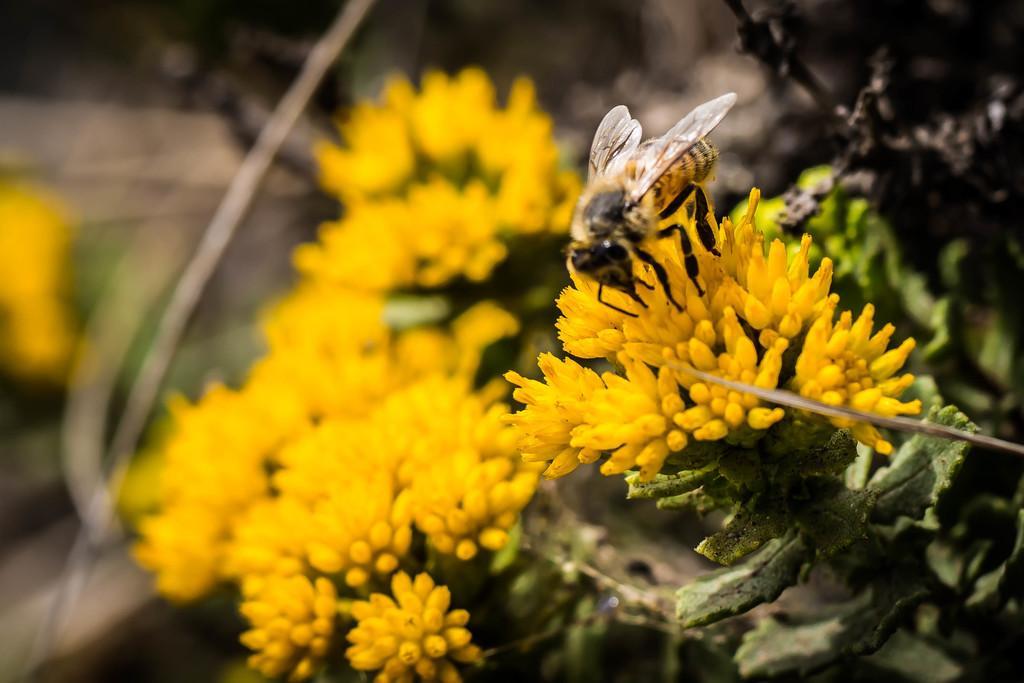Can you describe this image briefly? In this image in the foreground there are flowers and on the flowers there is a bee, and there is a blurry background. 